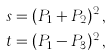<formula> <loc_0><loc_0><loc_500><loc_500>s & = ( P _ { 1 } + P _ { 2 } ) ^ { 2 } \, , \\ t & = ( P _ { 1 } - P _ { 3 } ) ^ { 2 } \, ,</formula> 